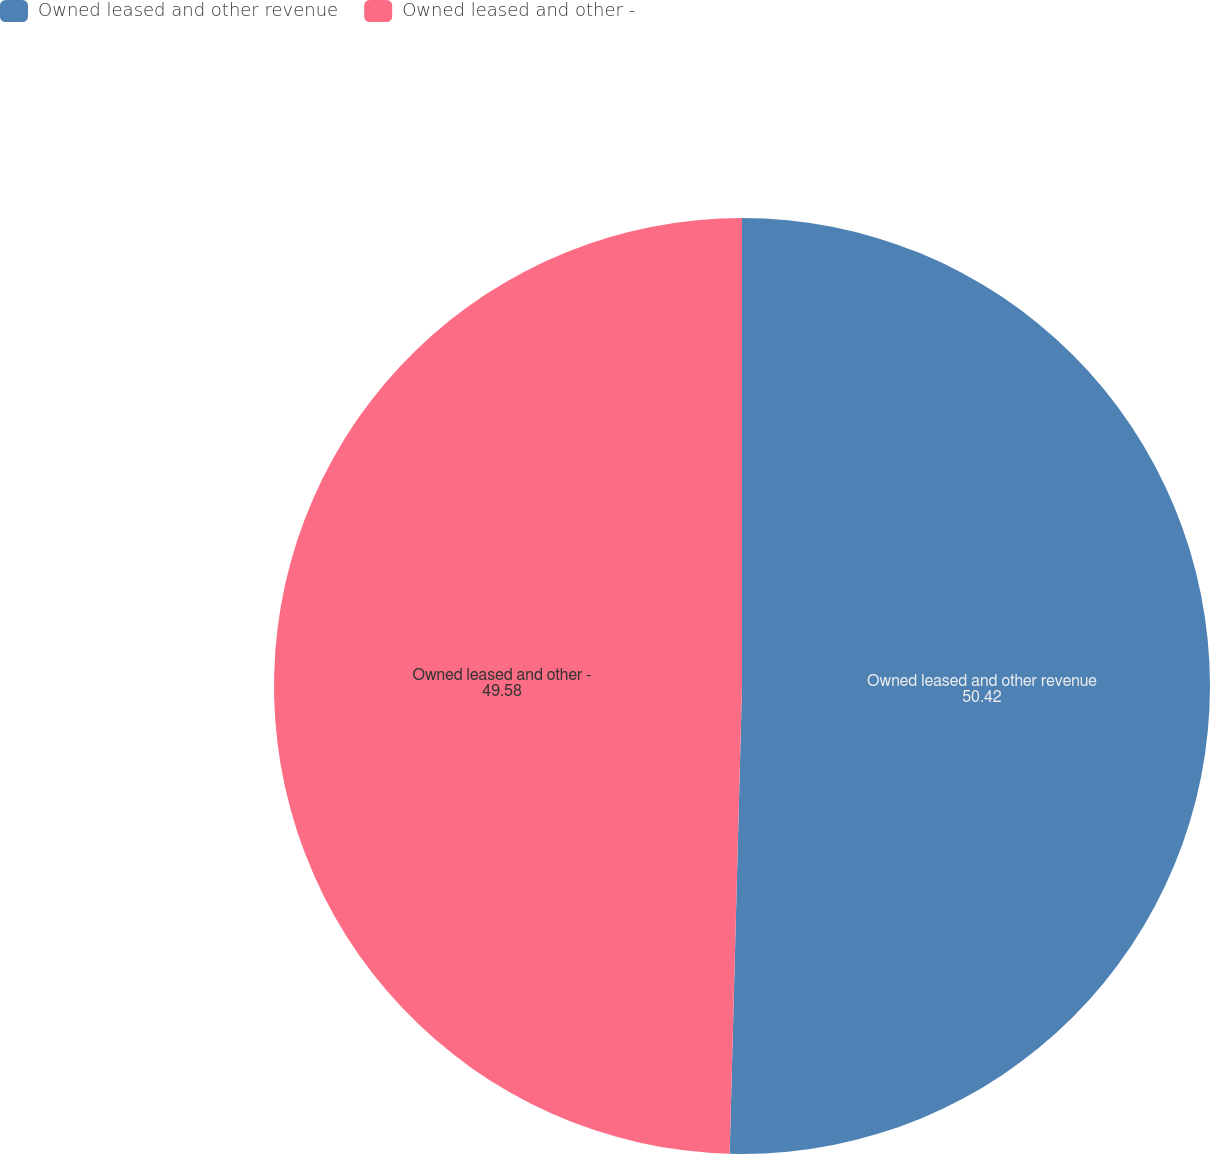Convert chart. <chart><loc_0><loc_0><loc_500><loc_500><pie_chart><fcel>Owned leased and other revenue<fcel>Owned leased and other -<nl><fcel>50.42%<fcel>49.58%<nl></chart> 